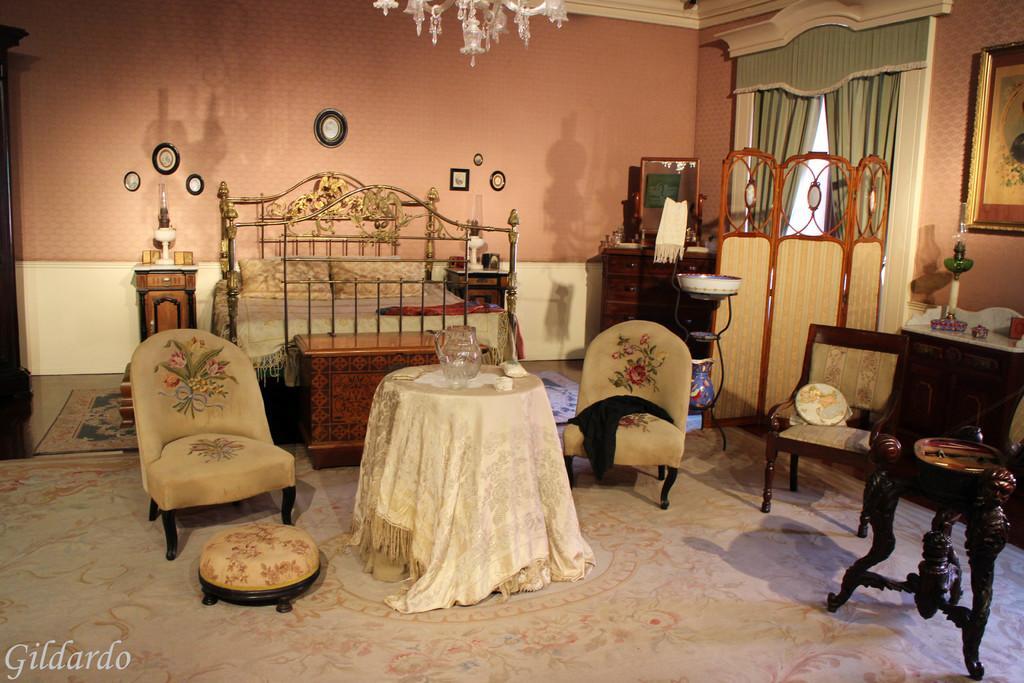Could you give a brief overview of what you see in this image? Here in this picture in the middle we can see a table and couple of chairs present on the floor over there and we can also see a stool over there and we behind that we can see a bed with pillows on it present over there and on the table we can see a bowl present, at the top we can see a chandelier and on the right side we can see a mirror present on the table over there and we can see window with curtains and on the left side we can see a candle present on the table over there and we can see stools and chairs here and there. 